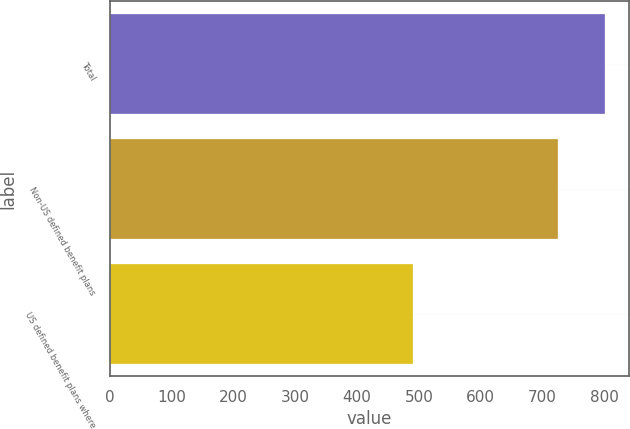<chart> <loc_0><loc_0><loc_500><loc_500><bar_chart><fcel>Total<fcel>Non-US defined benefit plans<fcel>US defined benefit plans where<nl><fcel>800.6<fcel>724.8<fcel>490<nl></chart> 